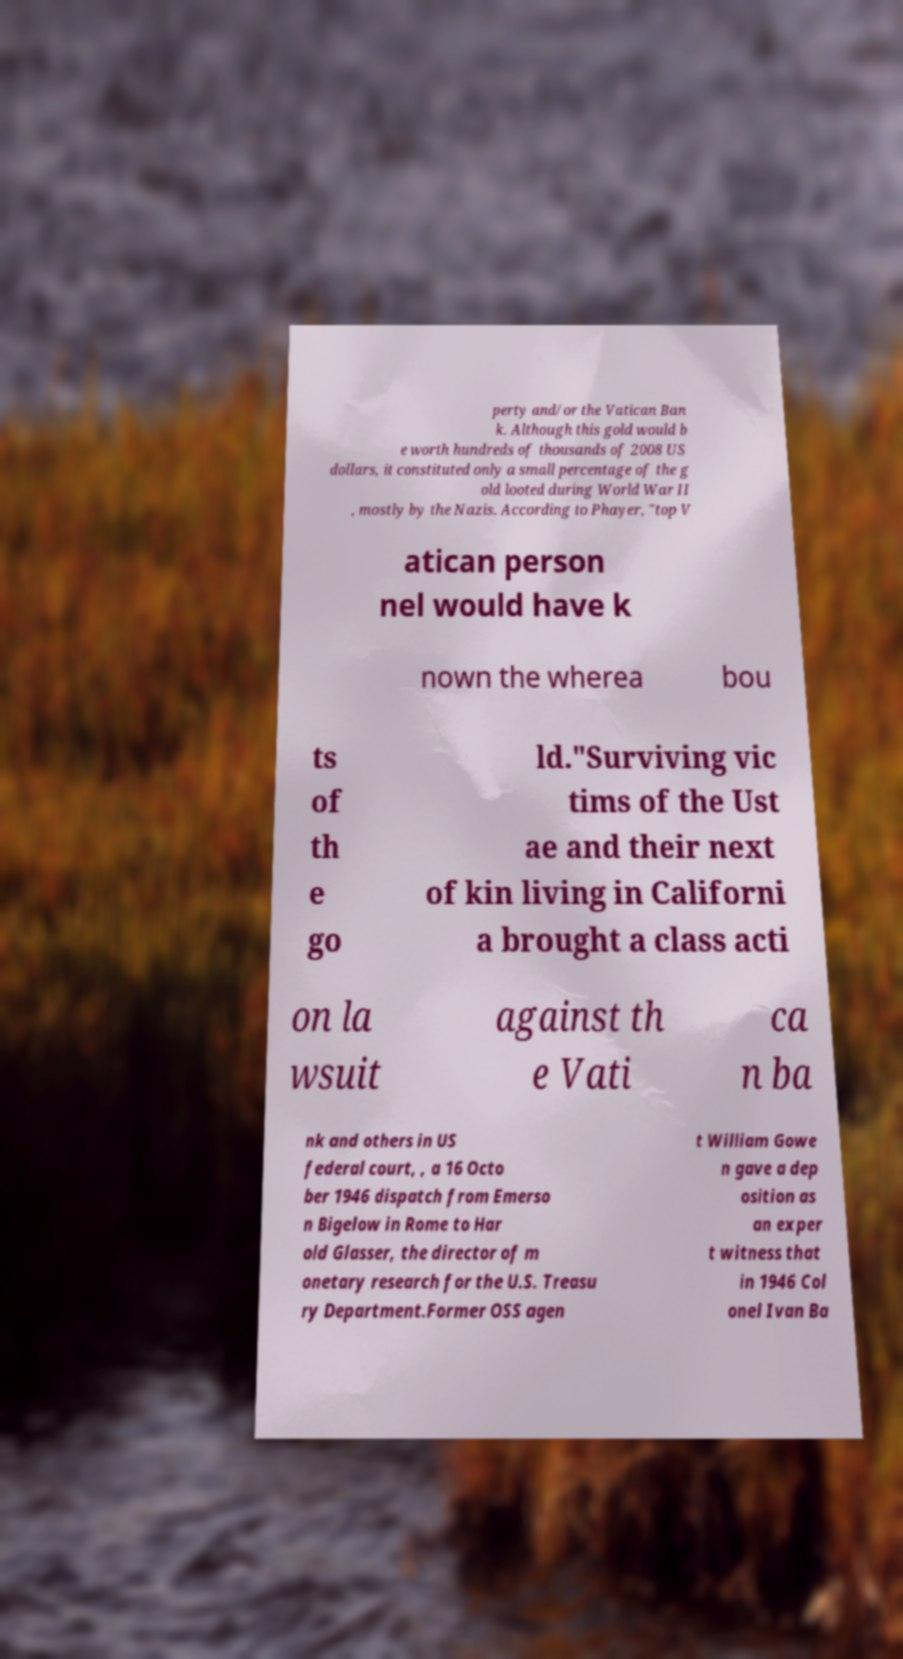There's text embedded in this image that I need extracted. Can you transcribe it verbatim? perty and/or the Vatican Ban k. Although this gold would b e worth hundreds of thousands of 2008 US dollars, it constituted only a small percentage of the g old looted during World War II , mostly by the Nazis. According to Phayer, "top V atican person nel would have k nown the wherea bou ts of th e go ld."Surviving vic tims of the Ust ae and their next of kin living in Californi a brought a class acti on la wsuit against th e Vati ca n ba nk and others in US federal court, , a 16 Octo ber 1946 dispatch from Emerso n Bigelow in Rome to Har old Glasser, the director of m onetary research for the U.S. Treasu ry Department.Former OSS agen t William Gowe n gave a dep osition as an exper t witness that in 1946 Col onel Ivan Ba 